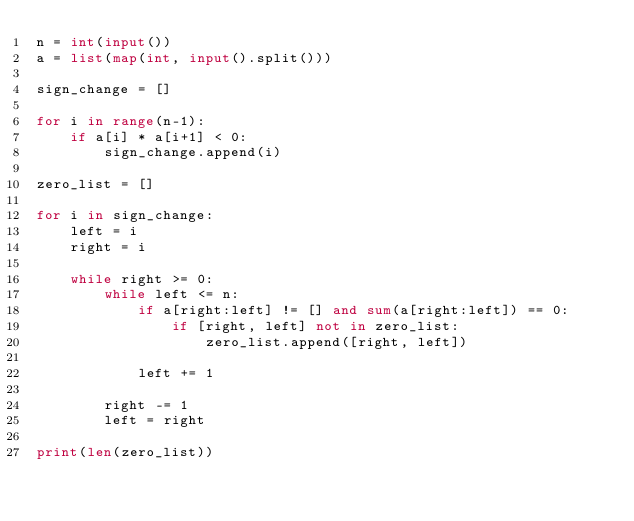<code> <loc_0><loc_0><loc_500><loc_500><_Python_>n = int(input())
a = list(map(int, input().split()))

sign_change = []

for i in range(n-1):
	if a[i] * a[i+1] < 0:
		sign_change.append(i)

zero_list = []

for i in sign_change:
	left = i
	right = i

	while right >= 0:
		while left <= n:
			if a[right:left] != [] and sum(a[right:left]) == 0:
				if [right, left] not in zero_list:
					zero_list.append([right, left])

			left += 1

		right -= 1
		left = right

print(len(zero_list))</code> 